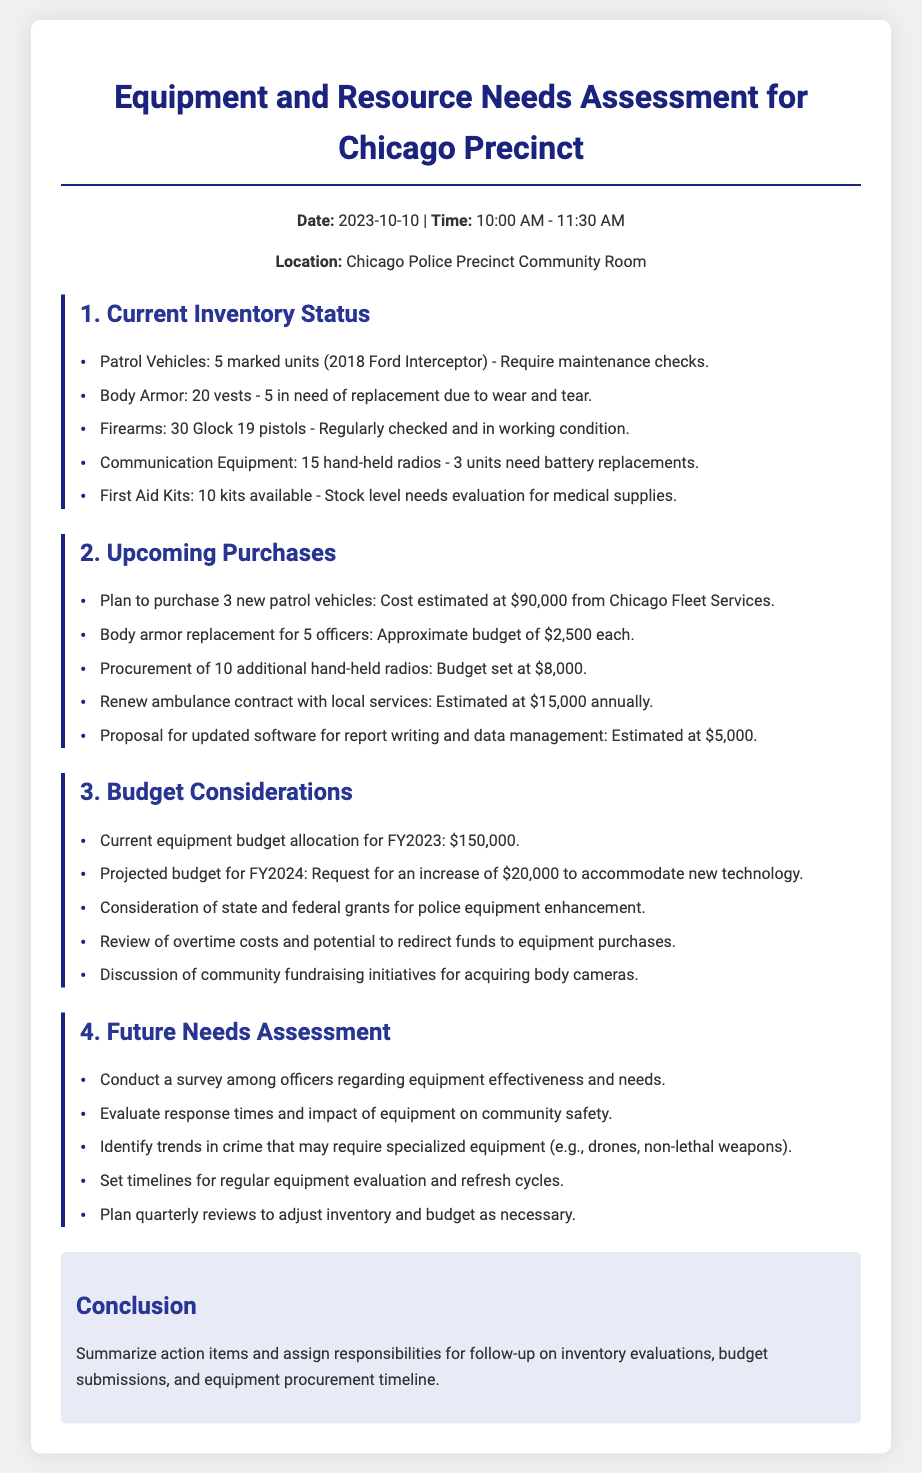What is the date of the assessment? The date of the assessment is stated as 2023-10-10 in the document.
Answer: 2023-10-10 How many patrol vehicles are currently in the inventory? The current inventory status lists 5 marked units of patrol vehicles.
Answer: 5 marked units What is the estimated cost for new patrol vehicles? The document mentions that the cost estimated for purchasing new patrol vehicles is $90,000.
Answer: $90,000 How many officers' body armor need replacement? The current inventory details that 5 of the body armor vests are in need of replacement.
Answer: 5 What is the total budget allocation for FY2023? The budget considerations section specifies that the current equipment budget allocation for FY2023 is $150,000.
Answer: $150,000 What equipment is proposed for future needs assessment? The future needs assessment section suggests conducting a survey among officers regarding equipment effectiveness.
Answer: Survey among officers What is the budget request increase for FY2024? The document states there is a request for an increase of $20,000 to accommodate new technology for FY2024.
Answer: $20,000 Which communication equipment needs battery replacements? The current inventory mentions that 3 units of hand-held radios need battery replacements.
Answer: 3 units What is the approximate cost for replacing body armor for 5 officers? The document indicates the approximate budget for body armor replacement is $2,500 each.
Answer: $2,500 each 